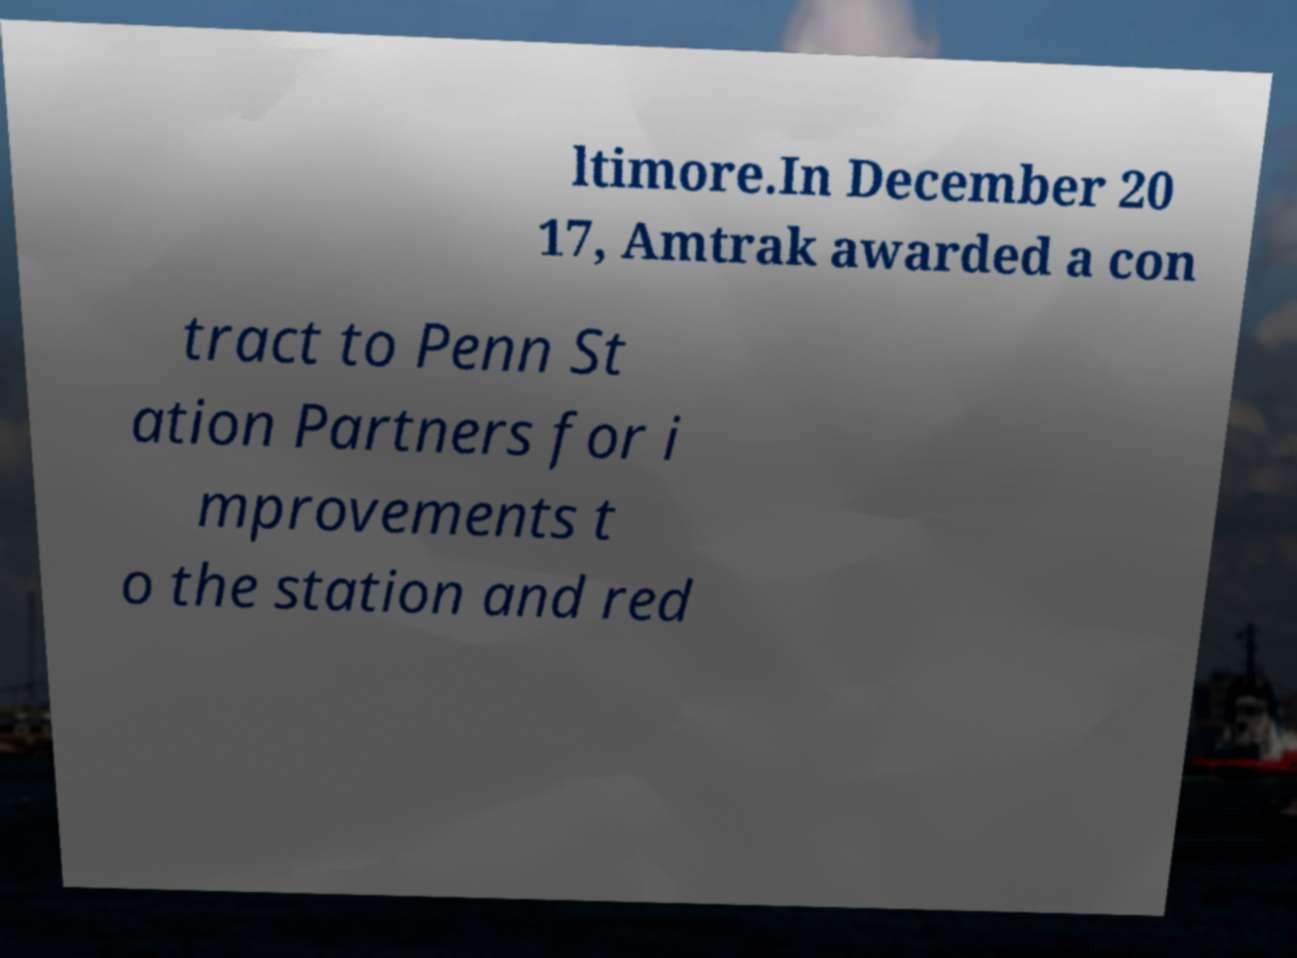Could you extract and type out the text from this image? ltimore.In December 20 17, Amtrak awarded a con tract to Penn St ation Partners for i mprovements t o the station and red 